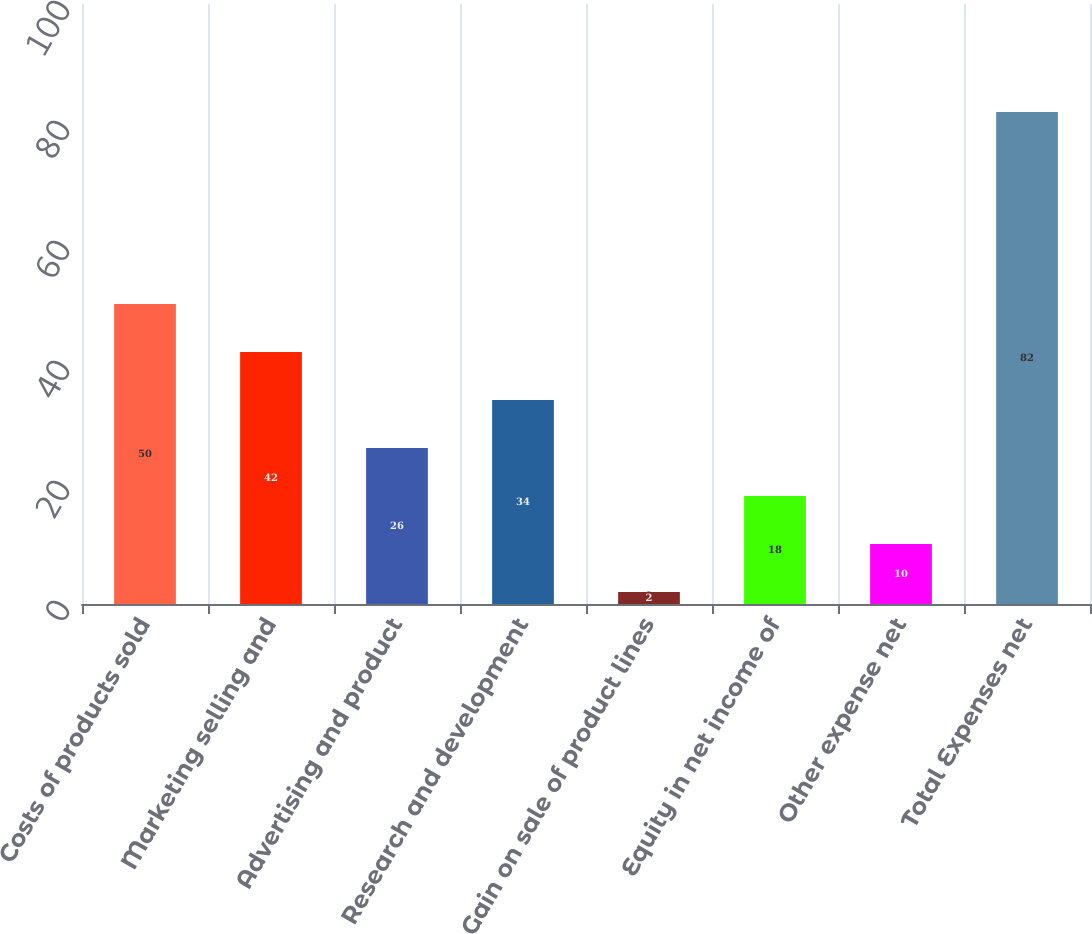Convert chart to OTSL. <chart><loc_0><loc_0><loc_500><loc_500><bar_chart><fcel>Costs of products sold<fcel>Marketing selling and<fcel>Advertising and product<fcel>Research and development<fcel>Gain on sale of product lines<fcel>Equity in net income of<fcel>Other expense net<fcel>Total Expenses net<nl><fcel>50<fcel>42<fcel>26<fcel>34<fcel>2<fcel>18<fcel>10<fcel>82<nl></chart> 